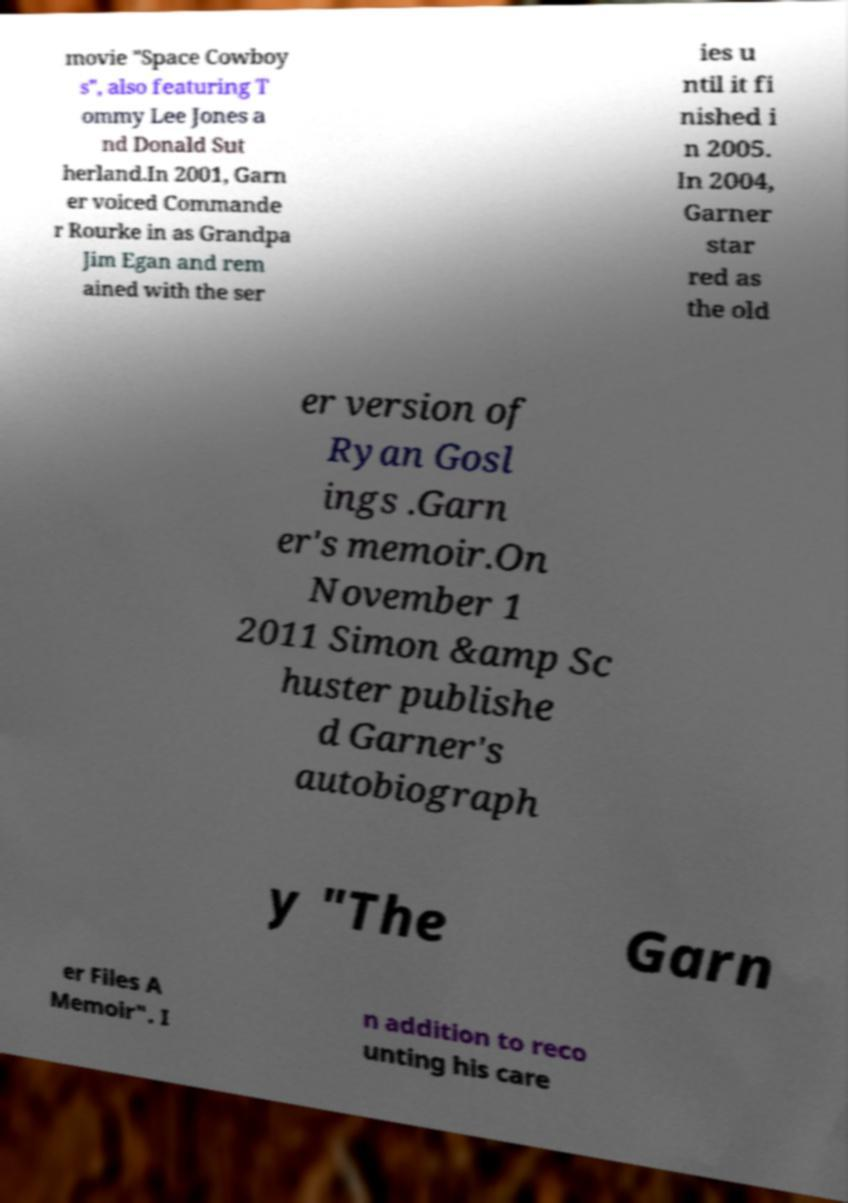I need the written content from this picture converted into text. Can you do that? movie "Space Cowboy s", also featuring T ommy Lee Jones a nd Donald Sut herland.In 2001, Garn er voiced Commande r Rourke in as Grandpa Jim Egan and rem ained with the ser ies u ntil it fi nished i n 2005. In 2004, Garner star red as the old er version of Ryan Gosl ings .Garn er's memoir.On November 1 2011 Simon &amp Sc huster publishe d Garner's autobiograph y "The Garn er Files A Memoir". I n addition to reco unting his care 